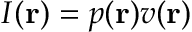Convert formula to latex. <formula><loc_0><loc_0><loc_500><loc_500>I ( { r } ) = p ( { r } ) v ( { r } )</formula> 